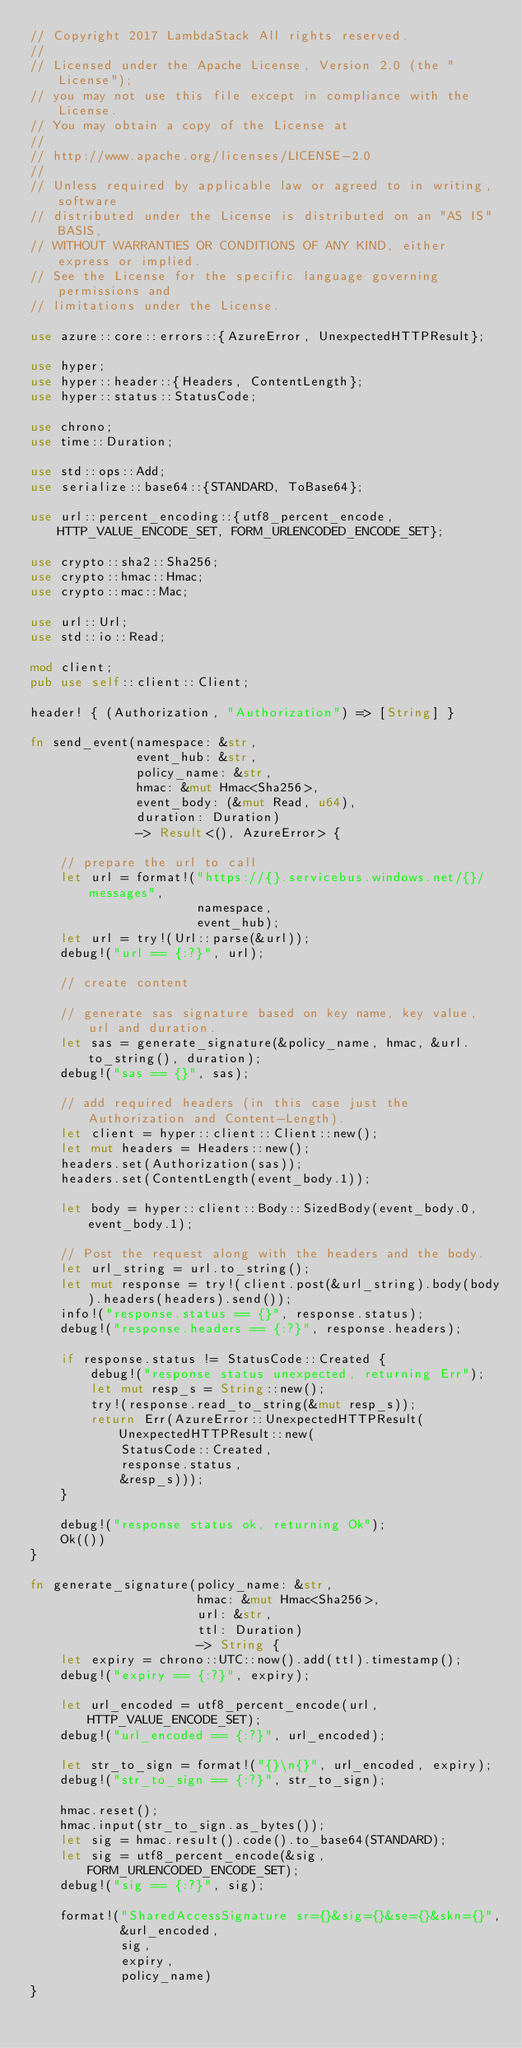<code> <loc_0><loc_0><loc_500><loc_500><_Rust_>// Copyright 2017 LambdaStack All rights reserved.
//
// Licensed under the Apache License, Version 2.0 (the "License");
// you may not use this file except in compliance with the License.
// You may obtain a copy of the License at
//
// http://www.apache.org/licenses/LICENSE-2.0
//
// Unless required by applicable law or agreed to in writing, software
// distributed under the License is distributed on an "AS IS" BASIS,
// WITHOUT WARRANTIES OR CONDITIONS OF ANY KIND, either express or implied.
// See the License for the specific language governing permissions and
// limitations under the License.

use azure::core::errors::{AzureError, UnexpectedHTTPResult};

use hyper;
use hyper::header::{Headers, ContentLength};
use hyper::status::StatusCode;

use chrono;
use time::Duration;

use std::ops::Add;
use serialize::base64::{STANDARD, ToBase64};

use url::percent_encoding::{utf8_percent_encode, HTTP_VALUE_ENCODE_SET, FORM_URLENCODED_ENCODE_SET};

use crypto::sha2::Sha256;
use crypto::hmac::Hmac;
use crypto::mac::Mac;

use url::Url;
use std::io::Read;

mod client;
pub use self::client::Client;

header! { (Authorization, "Authorization") => [String] }

fn send_event(namespace: &str,
              event_hub: &str,
              policy_name: &str,
              hmac: &mut Hmac<Sha256>,
              event_body: (&mut Read, u64),
              duration: Duration)
              -> Result<(), AzureError> {

    // prepare the url to call
    let url = format!("https://{}.servicebus.windows.net/{}/messages",
                      namespace,
                      event_hub);
    let url = try!(Url::parse(&url));
    debug!("url == {:?}", url);

    // create content

    // generate sas signature based on key name, key value, url and duration.
    let sas = generate_signature(&policy_name, hmac, &url.to_string(), duration);
    debug!("sas == {}", sas);

    // add required headers (in this case just the Authorization and Content-Length).
    let client = hyper::client::Client::new();
    let mut headers = Headers::new();
    headers.set(Authorization(sas));
    headers.set(ContentLength(event_body.1));

    let body = hyper::client::Body::SizedBody(event_body.0, event_body.1);

    // Post the request along with the headers and the body.
    let url_string = url.to_string();
    let mut response = try!(client.post(&url_string).body(body).headers(headers).send());
    info!("response.status == {}", response.status);
    debug!("response.headers == {:?}", response.headers);

    if response.status != StatusCode::Created {
        debug!("response status unexpected, returning Err");
        let mut resp_s = String::new();
        try!(response.read_to_string(&mut resp_s));
        return Err(AzureError::UnexpectedHTTPResult(UnexpectedHTTPResult::new(
            StatusCode::Created,
            response.status,
            &resp_s)));
    }

    debug!("response status ok, returning Ok");
    Ok(())
}

fn generate_signature(policy_name: &str,
                      hmac: &mut Hmac<Sha256>,
                      url: &str,
                      ttl: Duration)
                      -> String {
    let expiry = chrono::UTC::now().add(ttl).timestamp();
    debug!("expiry == {:?}", expiry);

    let url_encoded = utf8_percent_encode(url, HTTP_VALUE_ENCODE_SET);
    debug!("url_encoded == {:?}", url_encoded);

    let str_to_sign = format!("{}\n{}", url_encoded, expiry);
    debug!("str_to_sign == {:?}", str_to_sign);

    hmac.reset();
    hmac.input(str_to_sign.as_bytes());
    let sig = hmac.result().code().to_base64(STANDARD);
    let sig = utf8_percent_encode(&sig, FORM_URLENCODED_ENCODE_SET);
    debug!("sig == {:?}", sig);

    format!("SharedAccessSignature sr={}&sig={}&se={}&skn={}",
            &url_encoded,
            sig,
            expiry,
            policy_name)
}
</code> 